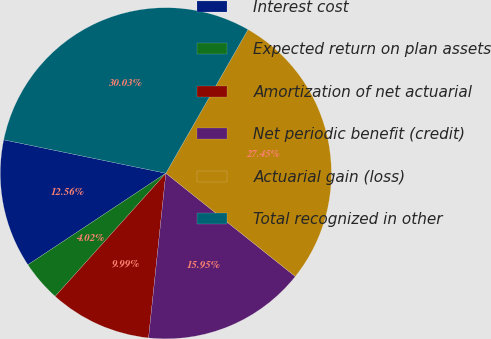Convert chart to OTSL. <chart><loc_0><loc_0><loc_500><loc_500><pie_chart><fcel>Interest cost<fcel>Expected return on plan assets<fcel>Amortization of net actuarial<fcel>Net periodic benefit (credit)<fcel>Actuarial gain (loss)<fcel>Total recognized in other<nl><fcel>12.56%<fcel>4.02%<fcel>9.99%<fcel>15.95%<fcel>27.45%<fcel>30.03%<nl></chart> 